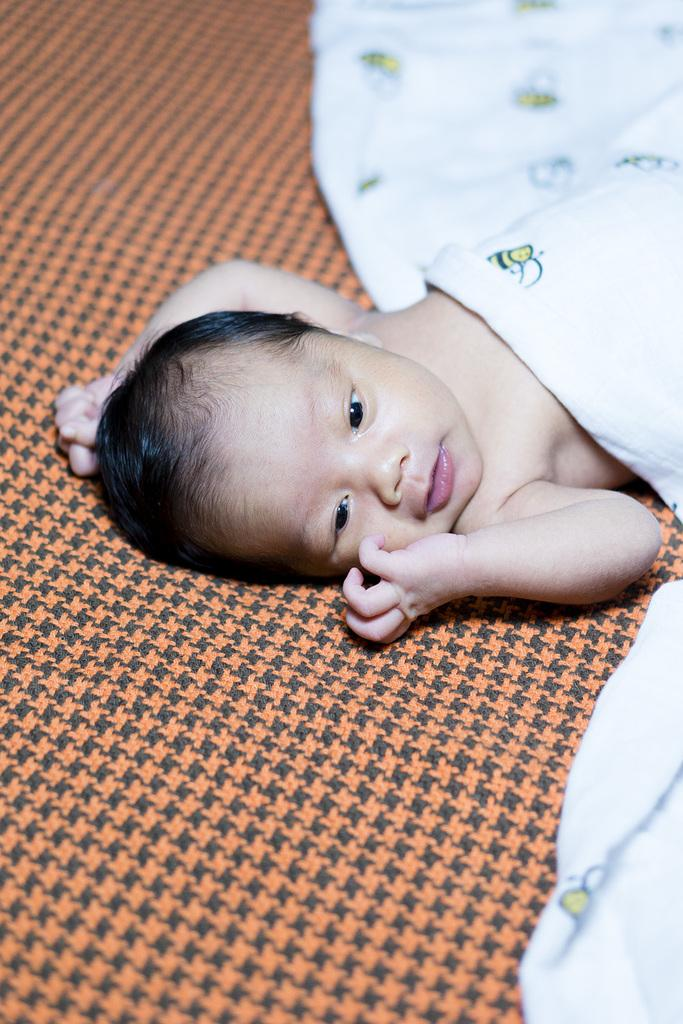What is the main subject of the image? There is a baby in the image. Where is the baby located? The baby is laying on a bed. What is covering part of the baby? The baby is partially covered with a white color cloth. What type of stem can be seen growing from the baby's head in the image? There is no stem growing from the baby's head in the image. What type of wine is being served to the baby in the image? There is no wine present in the image; it features a baby laying on a bed. 